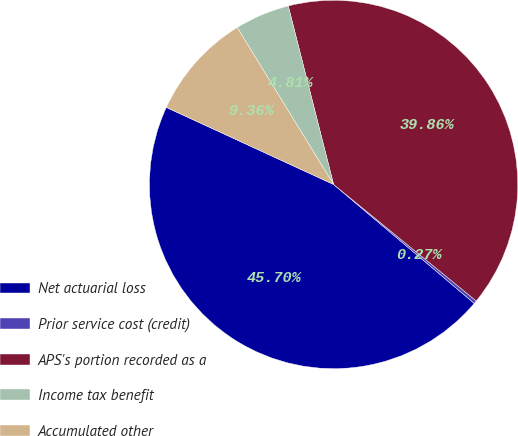Convert chart to OTSL. <chart><loc_0><loc_0><loc_500><loc_500><pie_chart><fcel>Net actuarial loss<fcel>Prior service cost (credit)<fcel>APS's portion recorded as a<fcel>Income tax benefit<fcel>Accumulated other<nl><fcel>45.7%<fcel>0.27%<fcel>39.86%<fcel>4.81%<fcel>9.36%<nl></chart> 